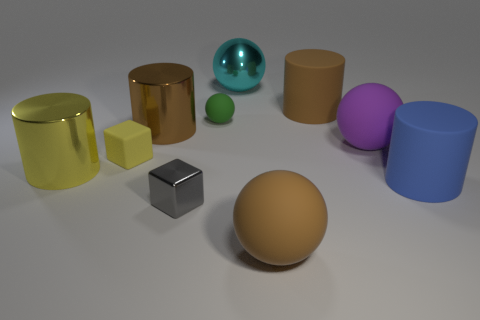How many rubber spheres are to the right of the big metal object that is behind the large brown cylinder to the right of the metal ball?
Give a very brief answer. 2. What is the size of the green thing?
Provide a short and direct response. Small. There is a purple sphere that is the same size as the blue thing; what is it made of?
Provide a succinct answer. Rubber. There is a tiny yellow rubber cube; how many cylinders are behind it?
Offer a terse response. 2. Is the large cylinder that is on the right side of the big purple matte object made of the same material as the big brown object in front of the purple matte thing?
Ensure brevity in your answer.  Yes. There is a big shiny thing to the right of the small object behind the large brown thing that is left of the cyan thing; what is its shape?
Provide a short and direct response. Sphere. What is the shape of the gray shiny object?
Make the answer very short. Cube. There is a blue rubber thing that is the same size as the yellow metallic cylinder; what shape is it?
Offer a very short reply. Cylinder. What number of other objects are the same color as the rubber cube?
Keep it short and to the point. 1. There is a large brown thing behind the large brown metallic thing; is its shape the same as the big brown thing in front of the big brown metal cylinder?
Your answer should be compact. No. 